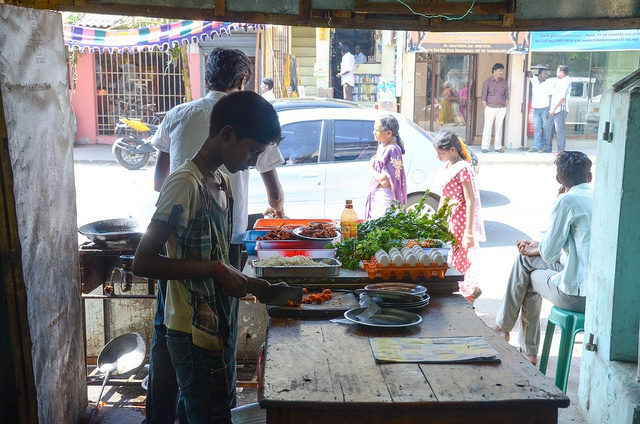Describe the objects in this image and their specific colors. I can see dining table in gray, darkgray, and black tones, people in gray, black, navy, and darkgreen tones, car in gray, white, and darkgray tones, people in gray, lightgray, lightblue, and darkgray tones, and people in gray, darkgray, black, and lightgray tones in this image. 